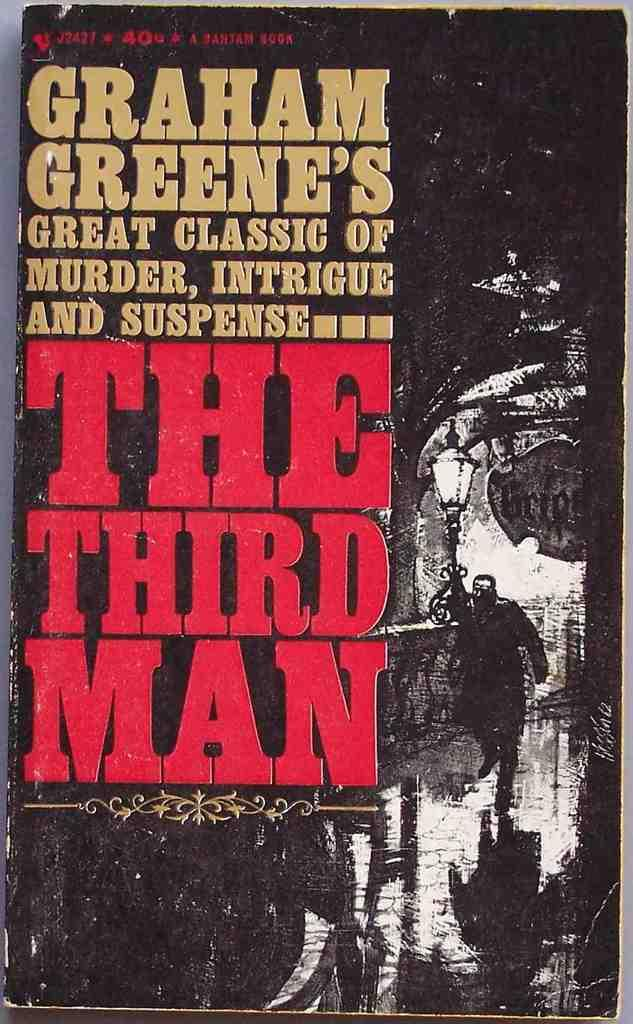What is the main object in the image that is in black color? There is a board or a book in the image, and it is in black color. What can be seen on the black object? There is text written on the board or book. What color is the text? The text is written in red color. What does the text say? The text says "The Third Man". What type of stone is visible in the image? There is no stone present in the image. How many orders are mentioned in the image? The image does not contain any information about orders. 